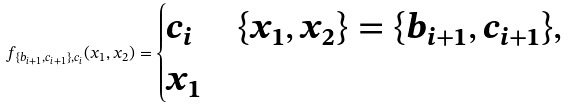<formula> <loc_0><loc_0><loc_500><loc_500>f _ { \{ b _ { i + 1 } , c _ { i + 1 } \} , c _ { i } } ( x _ { 1 } , x _ { 2 } ) = \begin{cases} c _ { i } & \{ x _ { 1 } , x _ { 2 } \} = \{ b _ { i + 1 } , c _ { i + 1 } \} , \\ x _ { 1 } & \end{cases}</formula> 